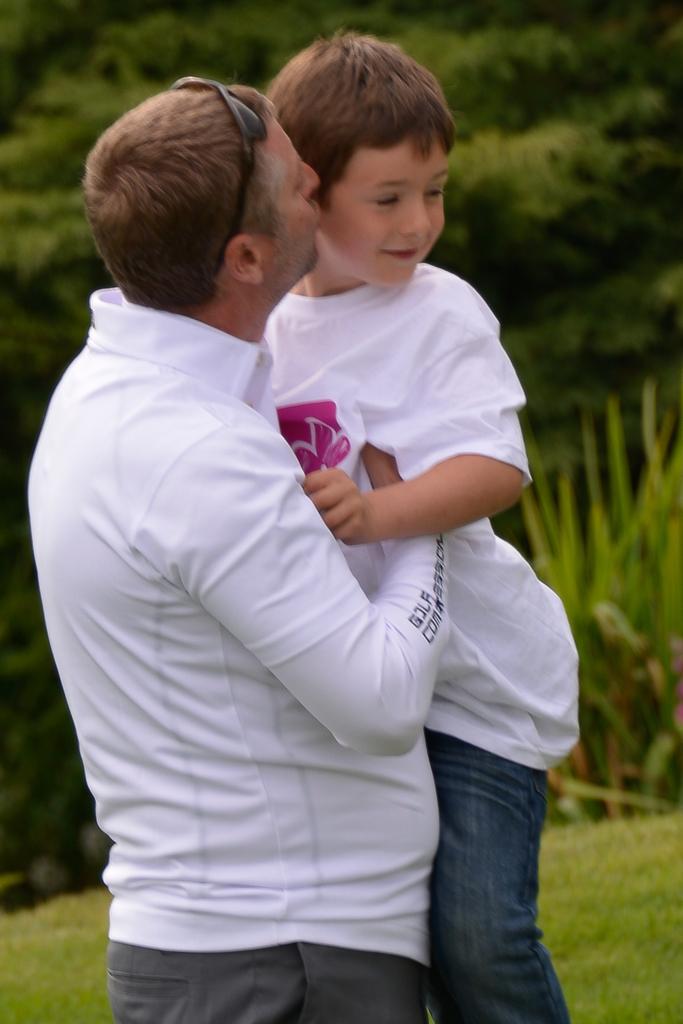How would you summarize this image in a sentence or two? In this image, I can see a man carrying and kissing a boy. In the background, there are trees, plants and grass. 